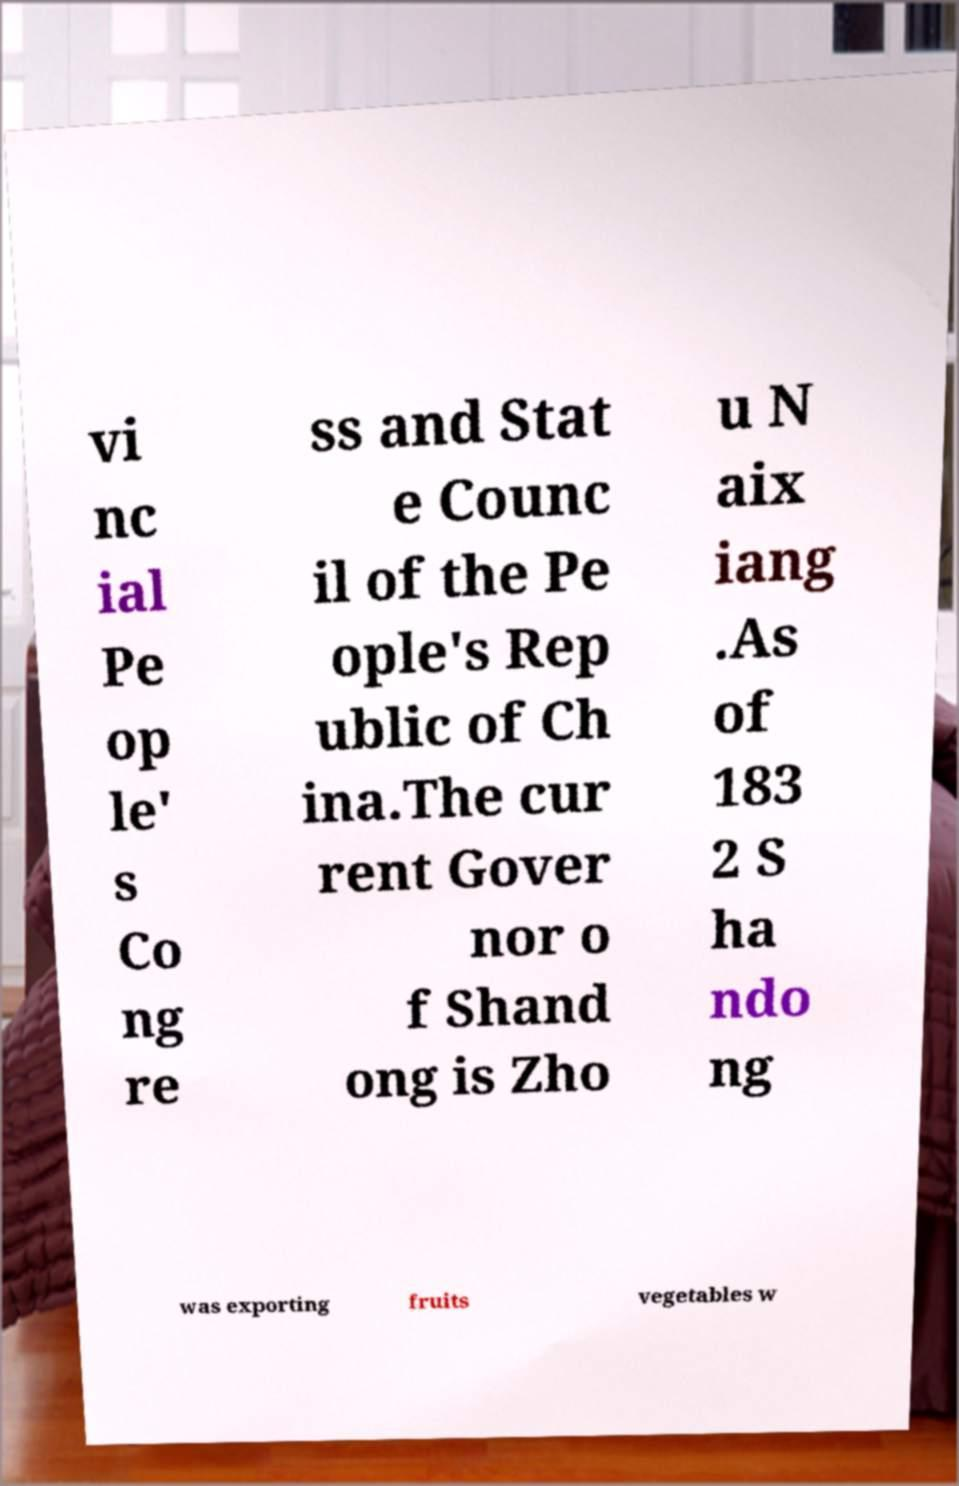I need the written content from this picture converted into text. Can you do that? vi nc ial Pe op le' s Co ng re ss and Stat e Counc il of the Pe ople's Rep ublic of Ch ina.The cur rent Gover nor o f Shand ong is Zho u N aix iang .As of 183 2 S ha ndo ng was exporting fruits vegetables w 